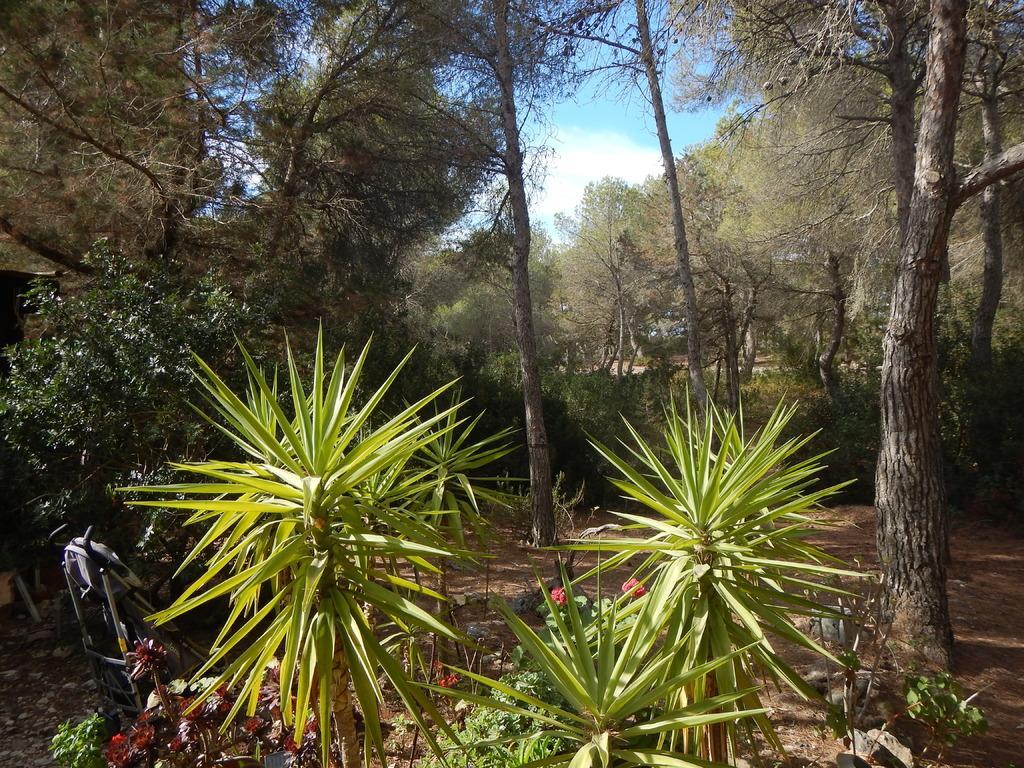Could you give a brief overview of what you see in this image? In this image in front there are plants. In the background of the image there are trees and sky. 